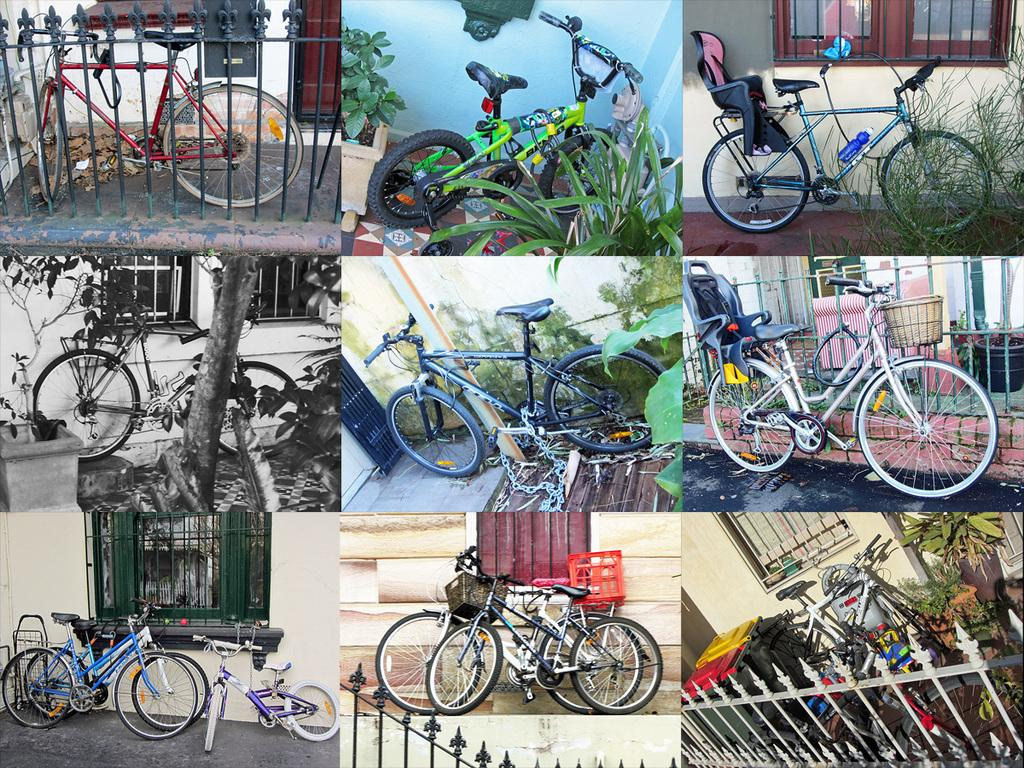What type of establishment is depicted in the image? The image is of a college. What mode of transportation can be seen in the image? There are cycles in the image. What architectural feature is present in the image? There is a wall in the image. What can be seen through the wall in the image? There are windows in the image. What type of vegetation is present in the image? There are plants in the image. What safety feature is present in the image? There is railing in the image. What entrance or exit is present in the image? There is a gate in the image. What other objects can be seen in the image? There are other objects in the image. What type of milk is being served in the image? There is no milk present in the image. What type of cloud can be seen in the image? There are no clouds present in the image. 